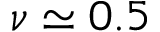Convert formula to latex. <formula><loc_0><loc_0><loc_500><loc_500>\nu \simeq 0 . 5</formula> 